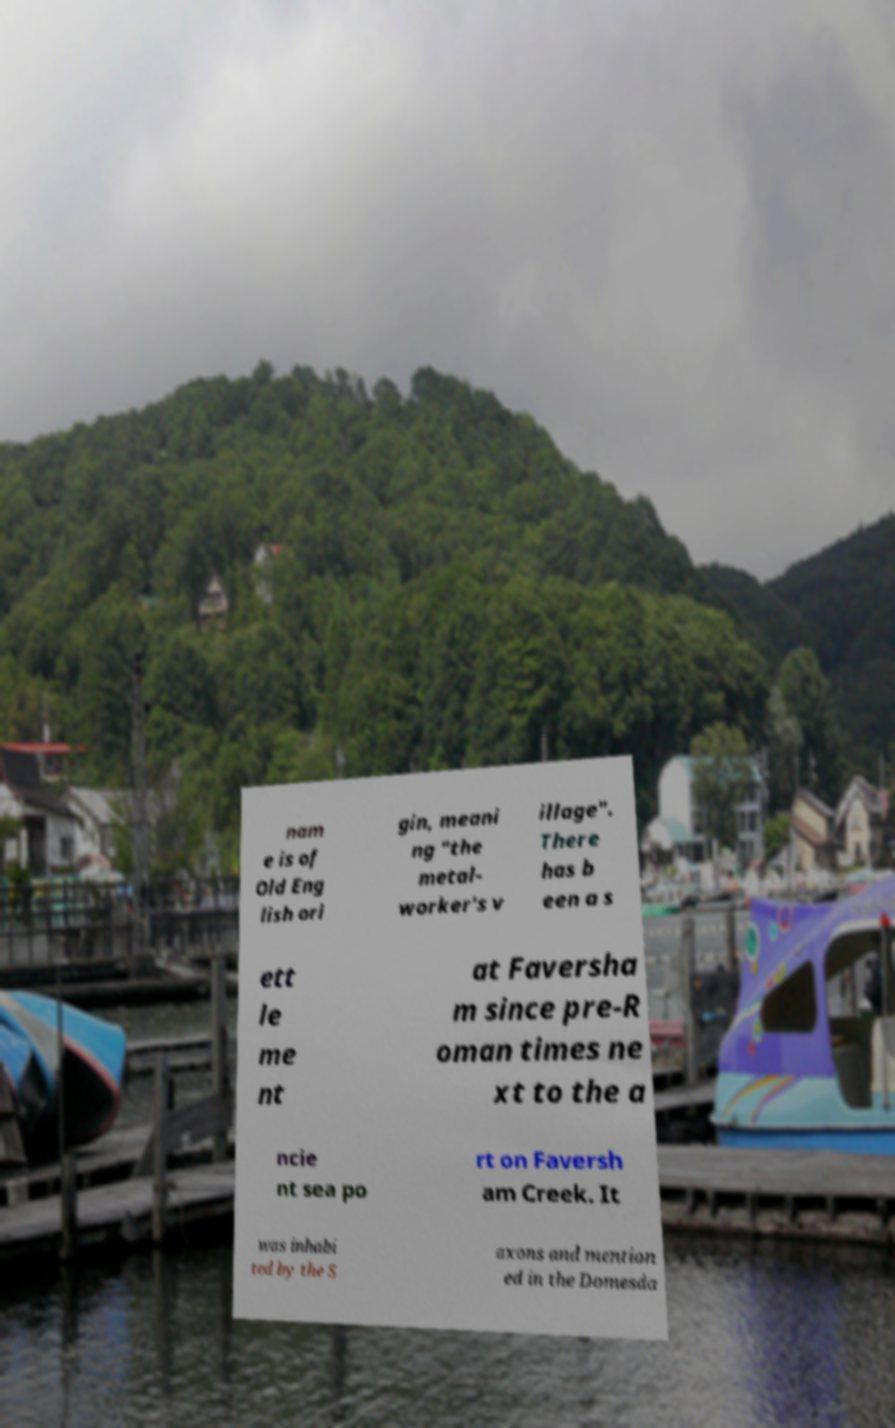What messages or text are displayed in this image? I need them in a readable, typed format. nam e is of Old Eng lish ori gin, meani ng "the metal- worker's v illage". There has b een a s ett le me nt at Faversha m since pre-R oman times ne xt to the a ncie nt sea po rt on Faversh am Creek. It was inhabi ted by the S axons and mention ed in the Domesda 